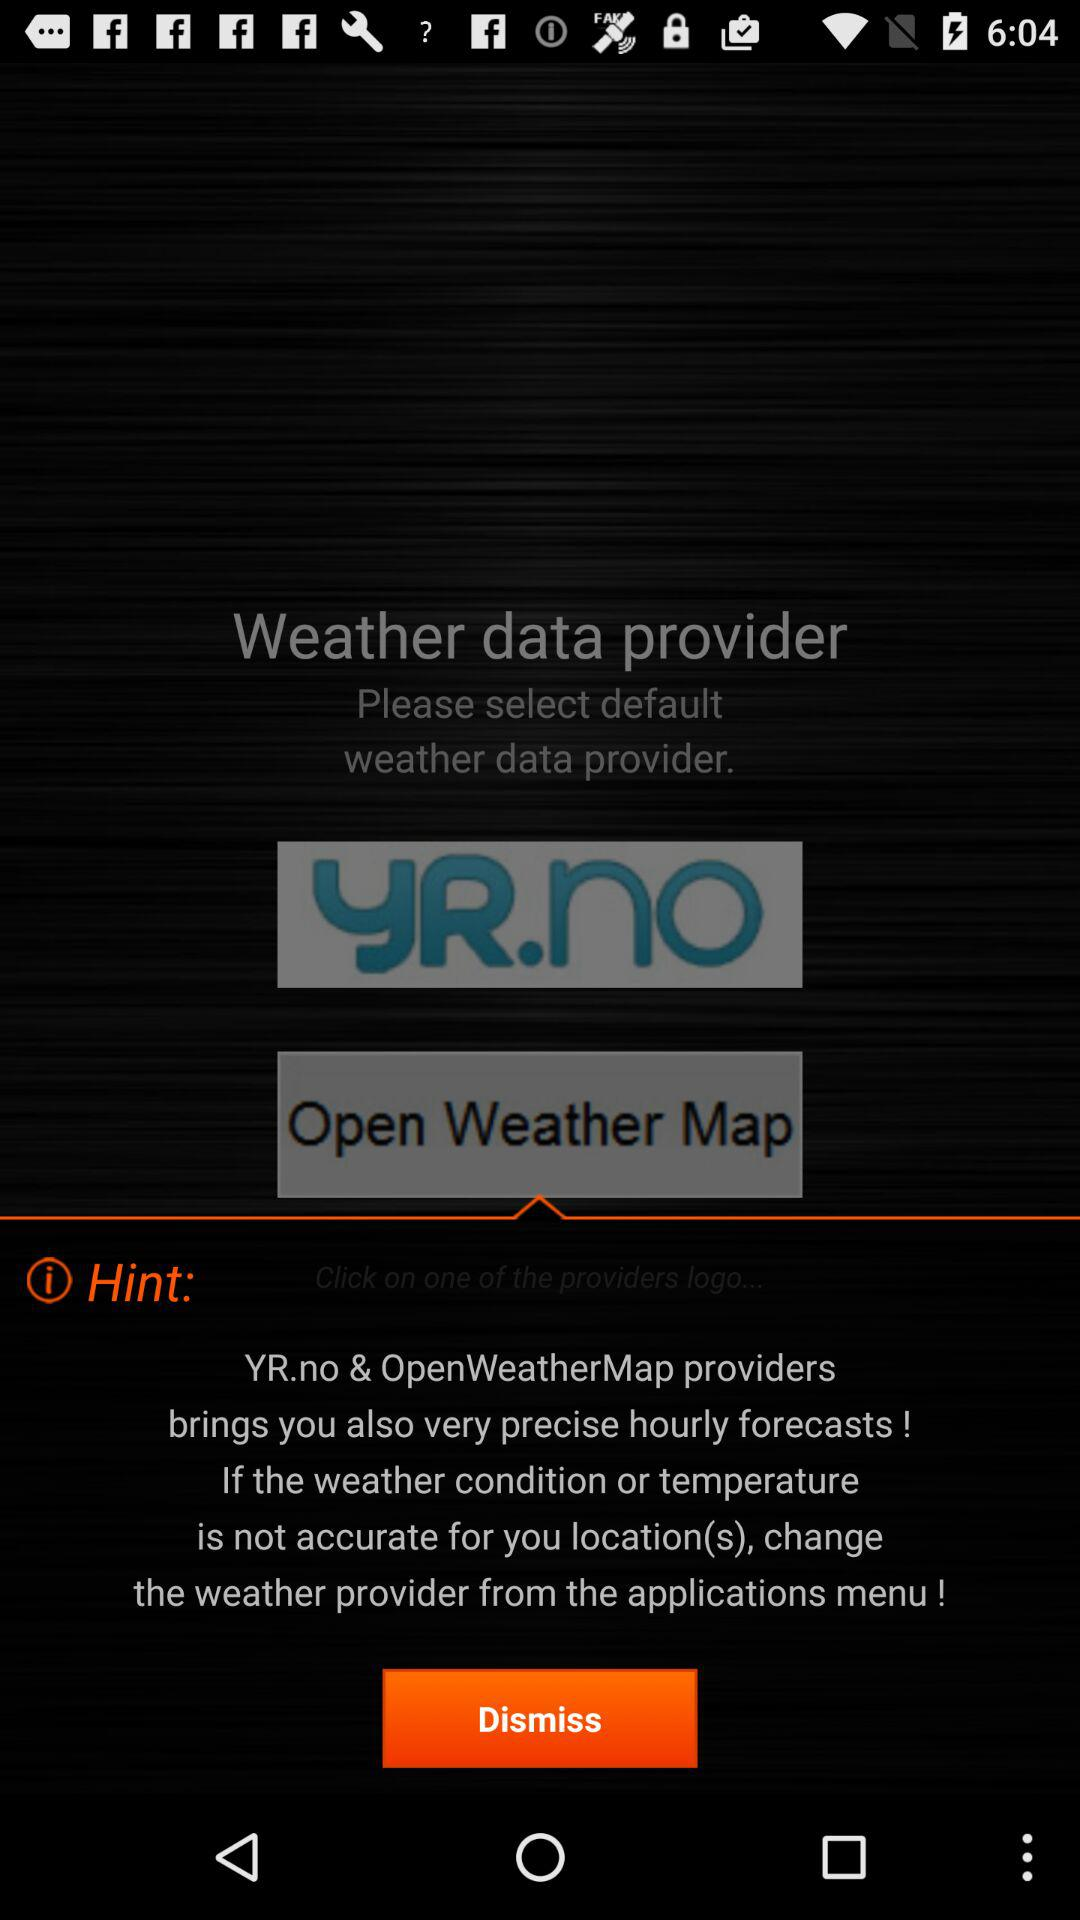What is the name of the application? The name of the application is "Weather data provider". 